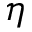Convert formula to latex. <formula><loc_0><loc_0><loc_500><loc_500>\eta</formula> 